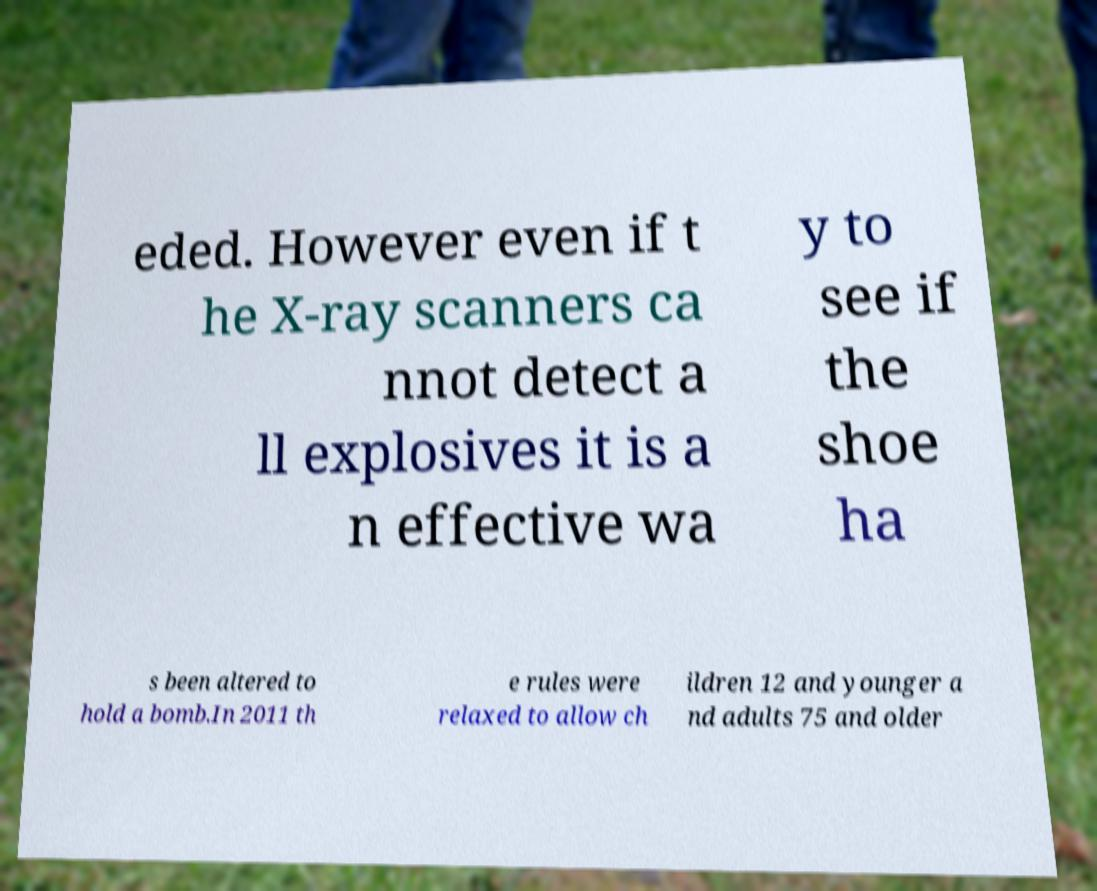Could you extract and type out the text from this image? eded. However even if t he X-ray scanners ca nnot detect a ll explosives it is a n effective wa y to see if the shoe ha s been altered to hold a bomb.In 2011 th e rules were relaxed to allow ch ildren 12 and younger a nd adults 75 and older 